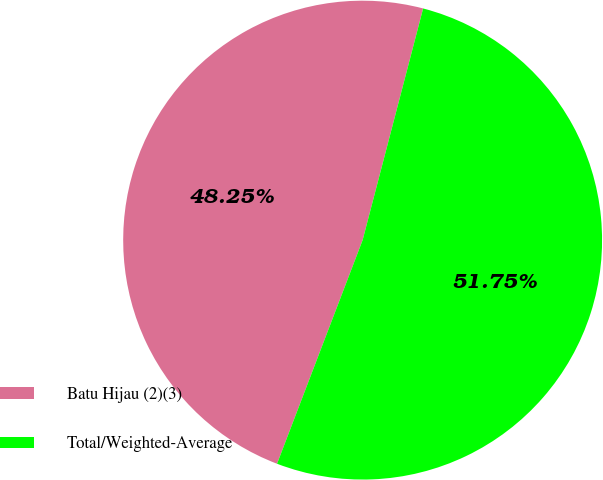Convert chart to OTSL. <chart><loc_0><loc_0><loc_500><loc_500><pie_chart><fcel>Batu Hijau (2)(3)<fcel>Total/Weighted-Average<nl><fcel>48.25%<fcel>51.75%<nl></chart> 